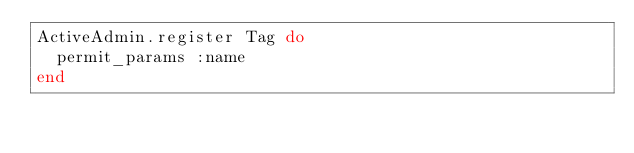Convert code to text. <code><loc_0><loc_0><loc_500><loc_500><_Ruby_>ActiveAdmin.register Tag do
  permit_params :name
end
</code> 